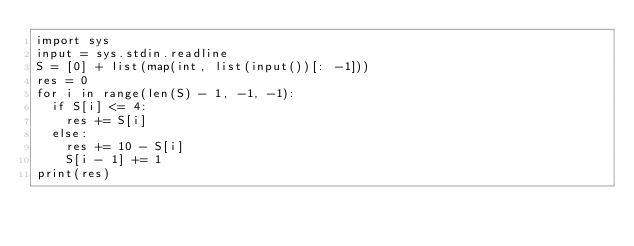<code> <loc_0><loc_0><loc_500><loc_500><_Python_>import sys
input = sys.stdin.readline
S = [0] + list(map(int, list(input())[: -1]))
res = 0
for i in range(len(S) - 1, -1, -1):
  if S[i] <= 4:
    res += S[i]
  else:
    res += 10 - S[i]
    S[i - 1] += 1
print(res)</code> 